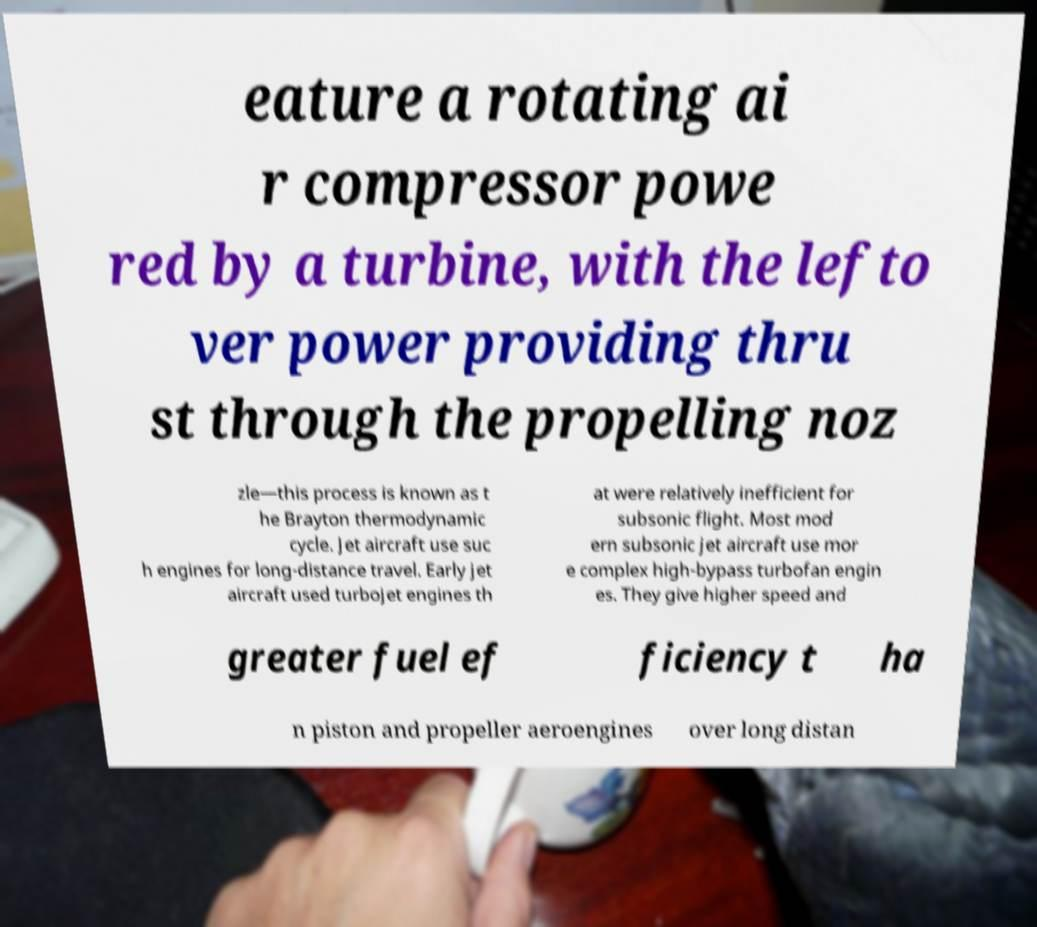Could you assist in decoding the text presented in this image and type it out clearly? eature a rotating ai r compressor powe red by a turbine, with the lefto ver power providing thru st through the propelling noz zle—this process is known as t he Brayton thermodynamic cycle. Jet aircraft use suc h engines for long-distance travel. Early jet aircraft used turbojet engines th at were relatively inefficient for subsonic flight. Most mod ern subsonic jet aircraft use mor e complex high-bypass turbofan engin es. They give higher speed and greater fuel ef ficiency t ha n piston and propeller aeroengines over long distan 